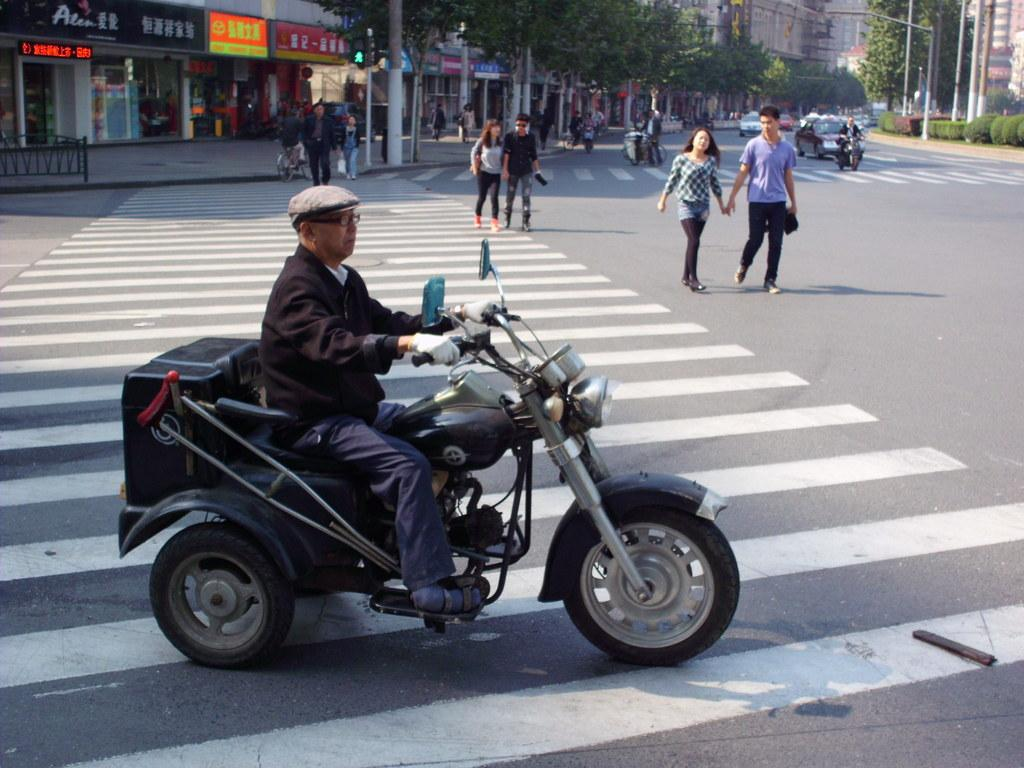What are the persons in the image doing? Some persons are walking, while others are sitting on a bike in the image. What can be seen on the road in the image? Vehicles are present on the road in the image. What is visible in the background of the image? Buildings, trees, and a pole are visible in the background of the image. Can you describe the attire of any person in the image? One person is wearing a cap, and another person is wearing glasses in the image. What type of plant is being discussed by the persons in the image? There is no plant present in the image, nor is there any discussion about a plant. What is the opinion of the girl in the image about the topic being discussed? There is no girl present in the image, and therefore no opinion can be attributed to her. 